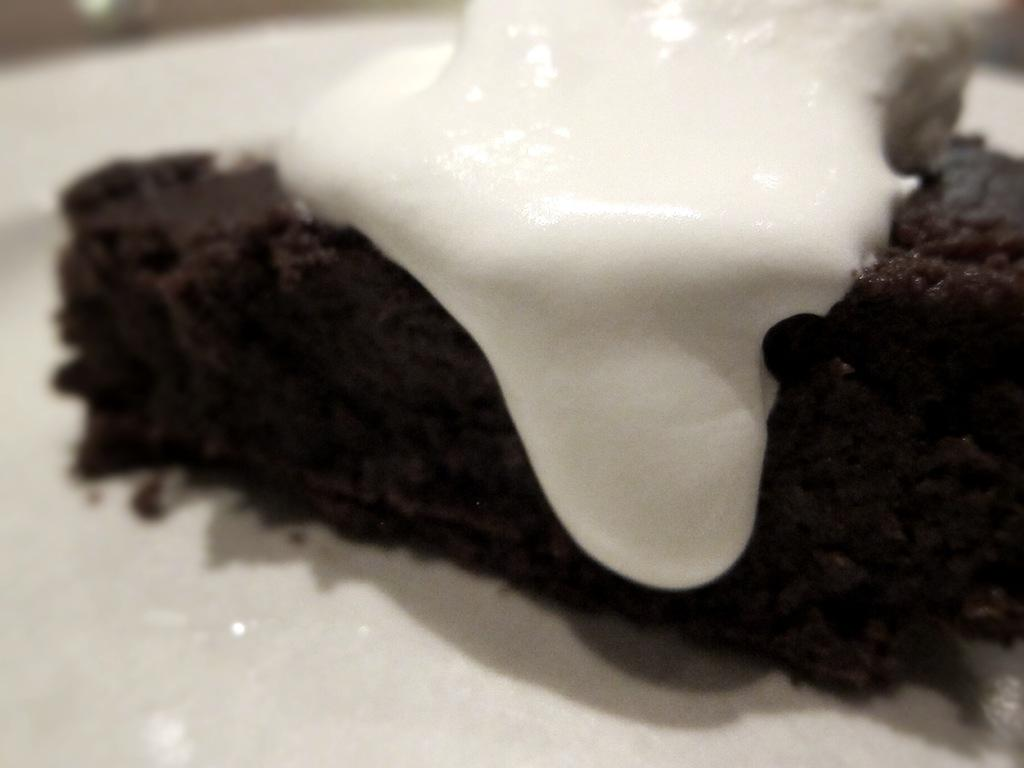What type of dessert is featured in the image? There is a chocolate cake in the image. Is there any additional topping on the chocolate cake? Yes, ice cream is present on the chocolate cake. How are the cake and ice cream arranged in the image? Both the cake and ice cream are on a platter. What type of produce is being harvested in the image? There is no produce being harvested in the image; it features a chocolate cake with ice cream on a platter. 